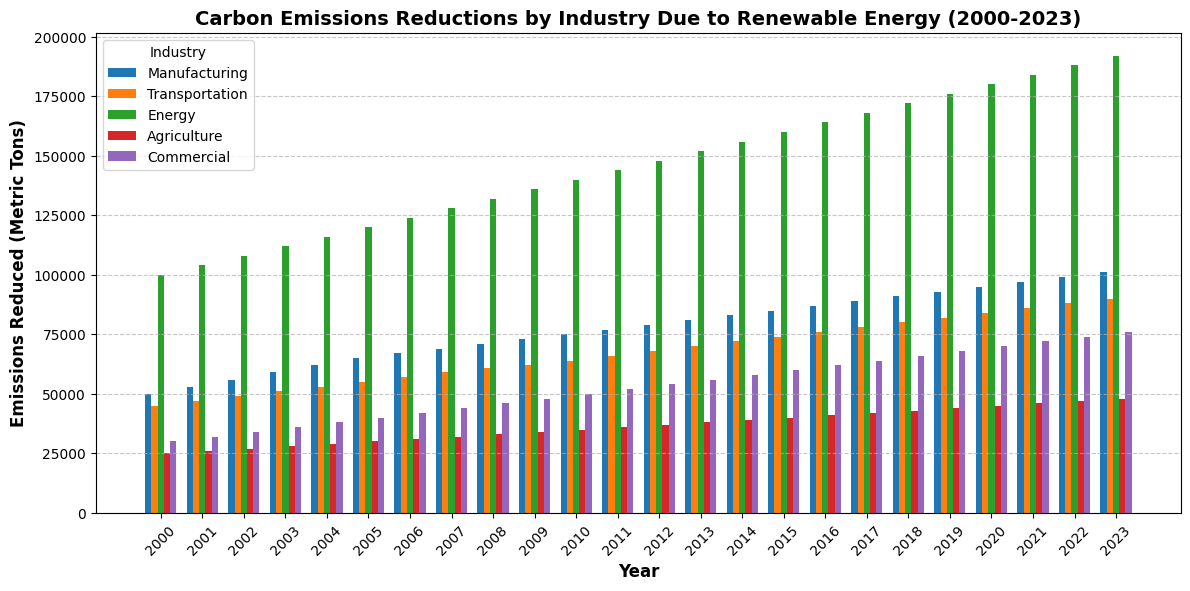What industry shows the greatest reduction in carbon emissions in 2023? To determine which industry shows the greatest reduction in 2023, look at the heights of the bars for each industry in that year. The tallest bar indicates the industry with the greatest reduction.
Answer: Energy How much did carbon emissions reduce cumulatively across all industries in 2000? To find the cumulative reduction, sum the heights of all bars for 2000 for each industry: Manufacturing (50,000) + Transportation (45,000) + Energy (100,000) + Agriculture (25,000) + Commercial (30,000).
Answer: 250,000 metric tons Which industry has consistently shown the lowest carbon emissions reduction from 2000 to 2023? Assess the height of bars for each year across all industries. The industry with the smallest bars consistently throughout the years will be the one with the lowest reductions.
Answer: Agriculture How did the carbon emissions reduction in Manufacturing in 2005 compare to Transportation in the same year? Compare the heights of the bars for Manufacturing and Transportation in 2005. Manufacturing (65,000) and Transportation (55,000).
Answer: Manufacturing is higher by 10,000 metric tons What is the average reduction of carbon emissions for the Commercial industry between 2000 and 2023? Sum the reduction values from 2000 to 2023 for the Commercial industry and then divide by the number of years (24). (30,000 + 32,000 + ... + 74,000 + 76,000) / 24.
Answer: 53,000 metric tons In which year did the Agriculture industry first exceed a 40,000 metric tons reduction? Examine the height of the bars for the Agriculture industry each year until you find the year where the value surpasses 40,000. The first year where this occurs is 2013.
Answer: 2013 Which year saw the smallest reduction in carbon emissions for the Transportation industry? Scan through the bars for the Transportation industry and find the year where the bar is the shortest. The smallest reduction occurs in the first year, which is 2000.
Answer: 2000 What is the total reduction in carbon emissions for the Energy industry from 2010 to 2020? Sum the reductions from 2010 to 2020 for the Energy industry: 140,000 + 144,000 + ... + 180,000.
Answer: 1,400,000 metric tons Between Agriculture and Commercial industries, which one saw a higher average annual increase in carbon emissions reduction from 2000 to 2023? Calculate the annual increase for each industry, then find the average: (Agriculture final - initial) / years and (Commercial final - initial) / years. Agriculture: (48,000 - 25,000) / 23 = 1,000 metric tons per year; Commercial: (76,000 - 30,000) / 23 ≈ 2,000 metric tons per year.
Answer: Commercial 